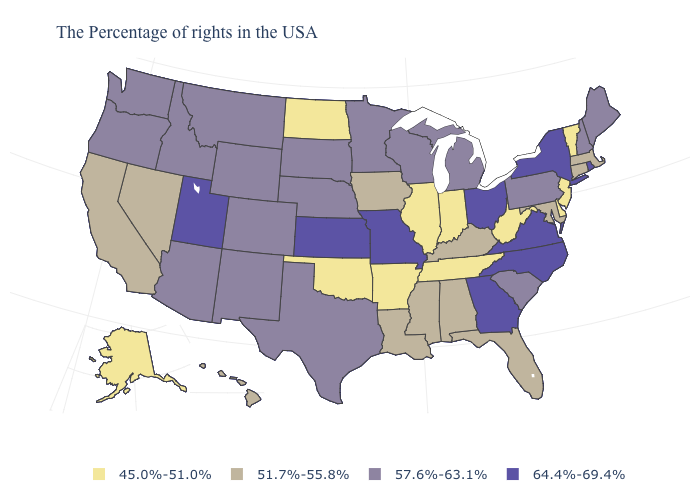Name the states that have a value in the range 51.7%-55.8%?
Quick response, please. Massachusetts, Connecticut, Maryland, Florida, Kentucky, Alabama, Mississippi, Louisiana, Iowa, Nevada, California, Hawaii. Does the map have missing data?
Be succinct. No. Name the states that have a value in the range 45.0%-51.0%?
Give a very brief answer. Vermont, New Jersey, Delaware, West Virginia, Indiana, Tennessee, Illinois, Arkansas, Oklahoma, North Dakota, Alaska. Which states hav the highest value in the Northeast?
Give a very brief answer. Rhode Island, New York. Is the legend a continuous bar?
Write a very short answer. No. Does Indiana have a lower value than Vermont?
Concise answer only. No. Name the states that have a value in the range 45.0%-51.0%?
Answer briefly. Vermont, New Jersey, Delaware, West Virginia, Indiana, Tennessee, Illinois, Arkansas, Oklahoma, North Dakota, Alaska. Name the states that have a value in the range 51.7%-55.8%?
Keep it brief. Massachusetts, Connecticut, Maryland, Florida, Kentucky, Alabama, Mississippi, Louisiana, Iowa, Nevada, California, Hawaii. How many symbols are there in the legend?
Be succinct. 4. Which states have the lowest value in the West?
Write a very short answer. Alaska. What is the value of Illinois?
Give a very brief answer. 45.0%-51.0%. What is the highest value in the West ?
Give a very brief answer. 64.4%-69.4%. Among the states that border Idaho , does Washington have the highest value?
Short answer required. No. What is the value of Oregon?
Concise answer only. 57.6%-63.1%. Name the states that have a value in the range 64.4%-69.4%?
Quick response, please. Rhode Island, New York, Virginia, North Carolina, Ohio, Georgia, Missouri, Kansas, Utah. 